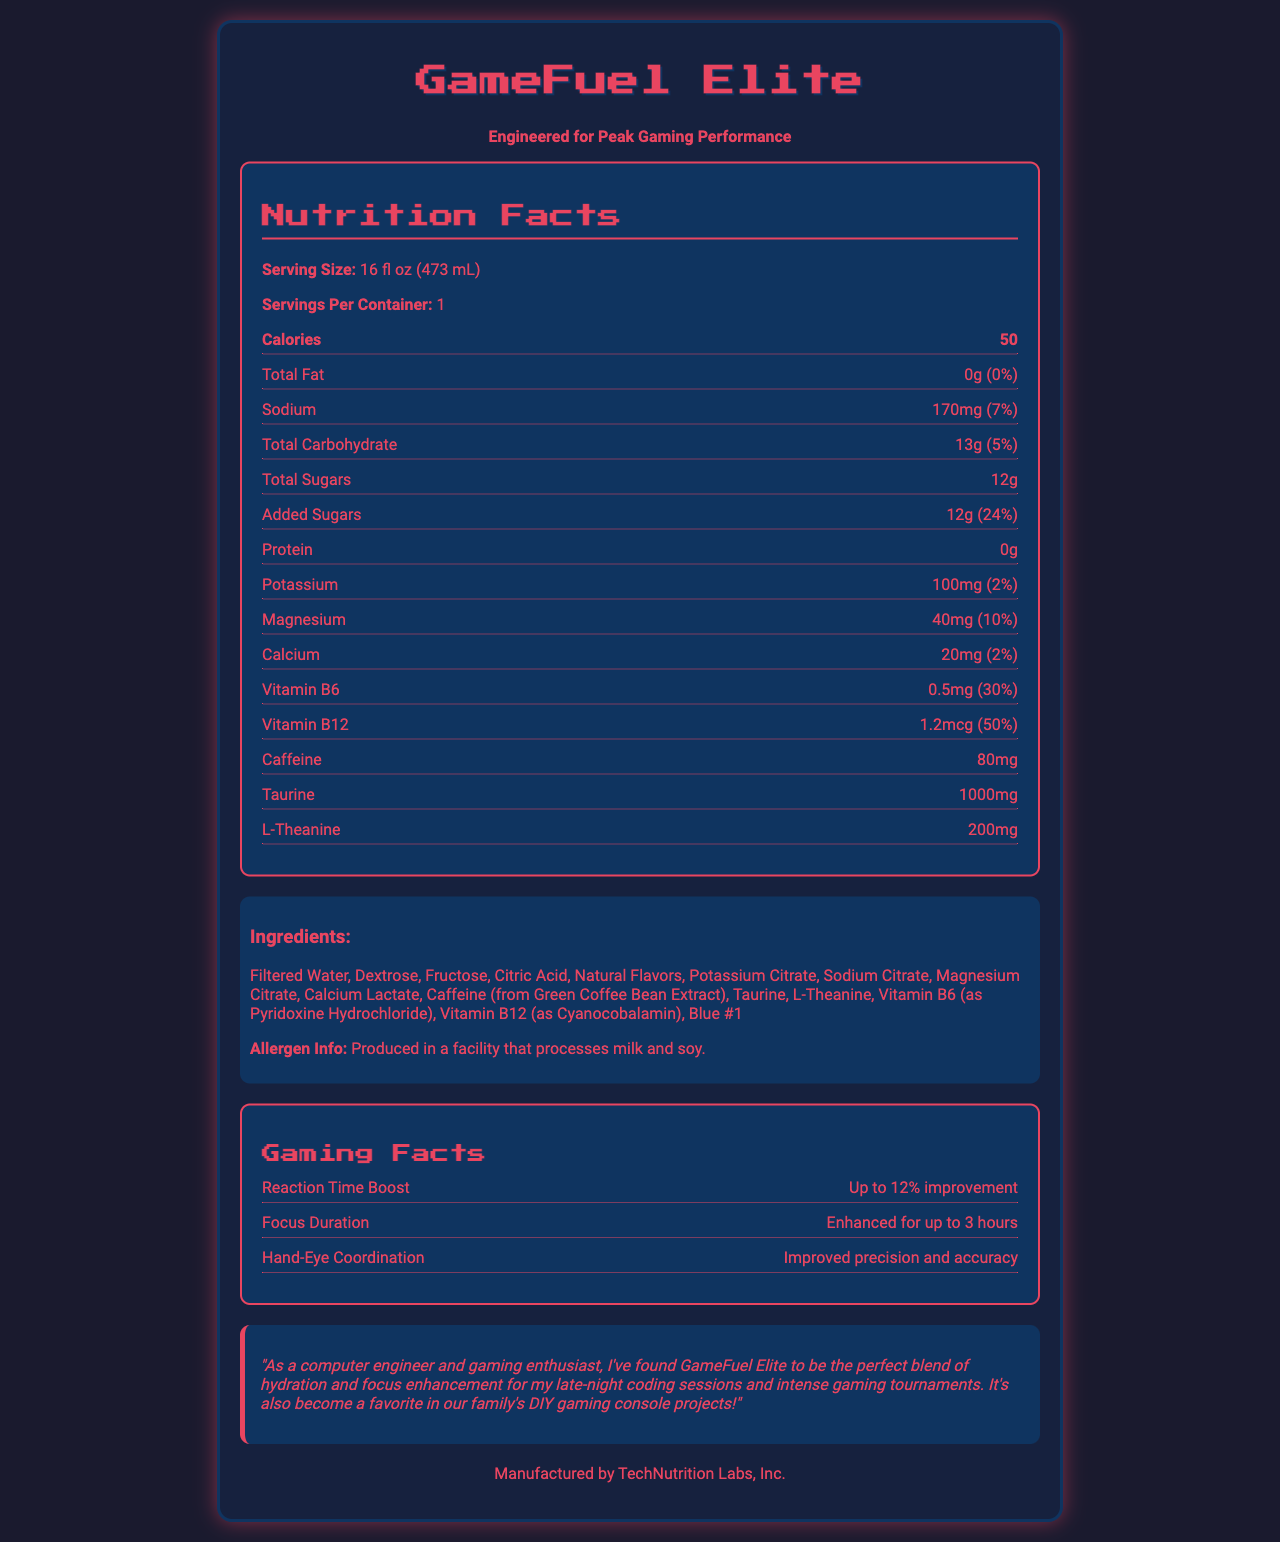what is the serving size of GameFuel Elite? The document lists the serving size as "16 fl oz (473 mL)" under the Nutrition Facts section.
Answer: 16 fl oz (473 mL) how many calories are in one serving? The Nutrition Facts section shows that there are 50 calories per serving.
Answer: 50 what is the percentage of daily value for sodium? The label states that the sodium content is 170mg, which is 7% of the daily value.
Answer: 7% how much caffeine does GameFuel Elite contain? The document indicates that there are 80mg of caffeine in one serving.
Answer: 80mg what ingredients are used in GameFuel Elite? The ingredients list is explicitly listed under the Ingredients section of the document.
Answer: Filtered Water, Dextrose, Fructose, Citric Acid, Natural Flavors, Potassium Citrate, Sodium Citrate, Magnesium Citrate, Calcium Lactate, Caffeine (from Green Coffee Bean Extract), Taurine, L-Theanine, Vitamin B6 (as Pyridoxine Hydrochloride), Vitamin B12 (as Cyanocobalamin), Blue #1 what company manufactures GameFuel Elite? The document clearly states that GameFuel Elite is manufactured by TechNutrition Labs, Inc.
Answer: TechNutrition Labs, Inc. how much taurine is in one serving? The Nutrition Facts section includes taurine content as 1000mg per serving.
Answer: 1000mg which vitamin B has the higher daily value percentage? A. Vitamin B6 B. Vitamin B12 Vitamin B6 is 30% of the daily value, while Vitamin B12 is 50% of the daily value, making Vitamin B12 higher.
Answer: B. Vitamin B12 what is the main idea of this document? The document combines detailed nutrition information, ingredients, and special benefits related to gaming performance, emphasizing that it is formulated to enhance focus and reaction time for e-sports competitors.
Answer: This document provides the Nutrition Facts and other relevant information for GameFuel Elite, an electrolyte-rich sports drink designed for e-sports competitors, highlighting its ingredients, benefits for gaming performance, and manufacturer's details. does GameFuel Elite contain any protein? The Nutrition Facts section shows that the amount of protein is 0g.
Answer: No what is the percentage of daily value for calcium in GameFuel Elite? A. 5% B. 2% C. 10% The document lists the calcium content as 20mg, which is 2% of the daily value.
Answer: B. 2% was GameFuel Elite produced in a facility that processes gluten? The allergen information in the document mentions milk and soy but does not provide any information about gluten.
Answer: Cannot be determined are there any added sugars in GameFuel Elite? The document states that the product contains 12g of total sugars, all of which are added sugars. This is 24% of the daily value.
Answer: Yes what type of acid is used in GameFuel Elite? The Ingredients section lists Citric Acid as one of the components.
Answer: Citric Acid what boosting effect does GameFuel Elite provide for reaction times? The Gaming Facts section mentions that GameFuel Elite can boost reaction times by up to 12%.
Answer: Up to 12% improvement is the drink colored with artificial colors? The ingredients list mentions Blue #1, which is an artificial color.
Answer: Yes what is the focus duration enhancement provided by GameFuel Elite? The Gaming Facts section states that focus is enhanced for up to 3 hours.
Answer: Enhanced for up to 3 hours how much potassium is in one serving of GameFuel Elite? A. 20mg B. 100mg C. 40mg D. 170mg The document lists the potassium content as 100mg per serving.
Answer: B. 100mg 